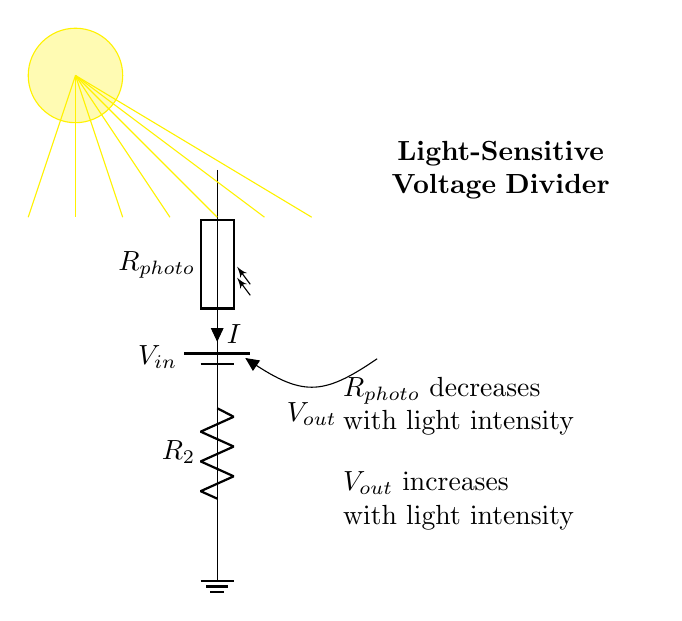What type of circuit is illustrated? The circuit is a voltage divider, which consists of two resistors, one variable (photoresistor) and one fixed resistor. This configuration divides the input voltage into a lower output voltage depending on the resistance of the components.
Answer: Voltage Divider What component decreases its resistance with light? The component that decreases its resistance with light intensity is called a photoresistor, which changes its resistance based on the ambient light level around it.
Answer: Photoresistor What is the role of the fixed resistor in this circuit? The fixed resistor, labeled as R2, provides a constant resistance and helps to set the output voltage level in combination with the photoresistor, allowing for voltage division according to the varying light levels.
Answer: Voltage division How does the output voltage change with increasing light intensity? As the light intensity increases, the resistance of the photoresistor decreases, which causes the output voltage (Vout) to increase due to the way voltage dividers function, where a lower resistance results in a higher proportion of the input voltage being output.
Answer: Increases What is the reference point for voltage measurements in the circuit? The reference point for voltage measurements in the circuit is the ground, which is the point at zero volts and is used as the baseline for measuring potential difference across circuit components.
Answer: Ground What happens to the output voltage when it is completely dark? In complete darkness, the resistance of the photoresistor becomes very high, nearly acting like an open circuit, resulting in the output voltage being very low or approaching zero because most of the input voltage drops across the photoresistor.
Answer: Approaches zero 